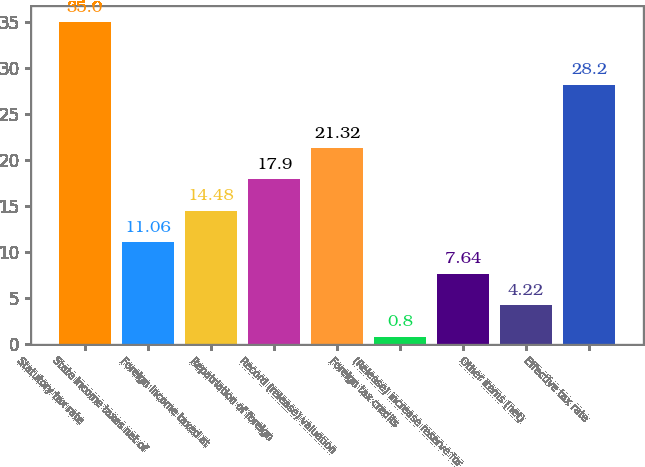Convert chart to OTSL. <chart><loc_0><loc_0><loc_500><loc_500><bar_chart><fcel>Statutory tax rate<fcel>State income taxes net of<fcel>Foreign income taxed at<fcel>Repatriation of foreign<fcel>Record (release) valuation<fcel>Foreign tax credits<fcel>(Release) increase reserve for<fcel>Other items (net)<fcel>Effective tax rate<nl><fcel>35<fcel>11.06<fcel>14.48<fcel>17.9<fcel>21.32<fcel>0.8<fcel>7.64<fcel>4.22<fcel>28.2<nl></chart> 